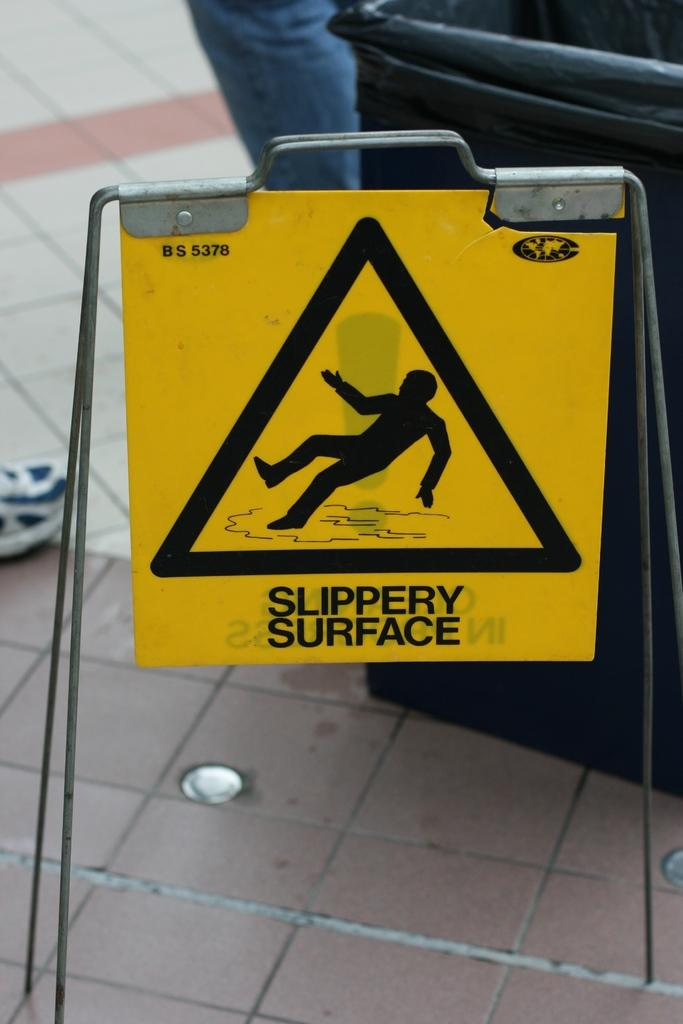Provide a one-sentence caption for the provided image. A tile floor with a Slippery Surface sign along it next to a trash can. 